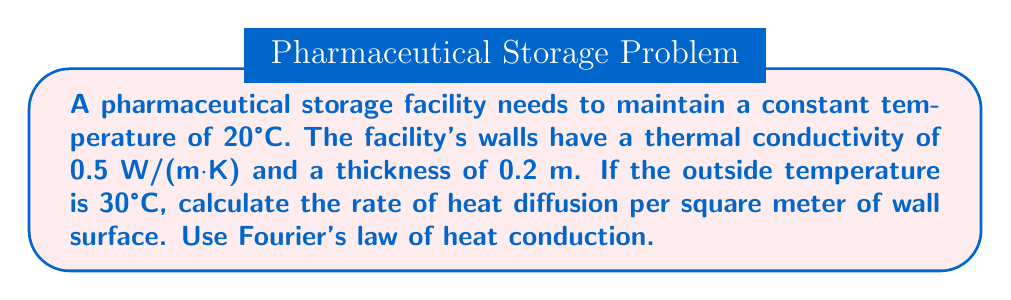What is the answer to this math problem? To solve this problem, we'll use Fourier's law of heat conduction:

$$q = -k \frac{dT}{dx}$$

Where:
$q$ = heat flux (W/m²)
$k$ = thermal conductivity (W/(m·K))
$\frac{dT}{dx}$ = temperature gradient (K/m)

Step 1: Identify the given values
- $k = 0.5$ W/(m·K)
- Wall thickness, $L = 0.2$ m
- Temperature inside, $T_1 = 20°C = 293.15$ K
- Temperature outside, $T_2 = 30°C = 303.15$ K

Step 2: Calculate the temperature gradient
$$\frac{dT}{dx} = \frac{T_2 - T_1}{L} = \frac{303.15 - 293.15}{0.2} = 50 \text{ K/m}$$

Step 3: Apply Fourier's law
$$q = -k \frac{dT}{dx} = -(0.5 \text{ W/(m·K)}) \times (50 \text{ K/m}) = -25 \text{ W/m²}$$

The negative sign indicates that heat flows from the higher temperature (outside) to the lower temperature (inside).
Answer: 25 W/m² 